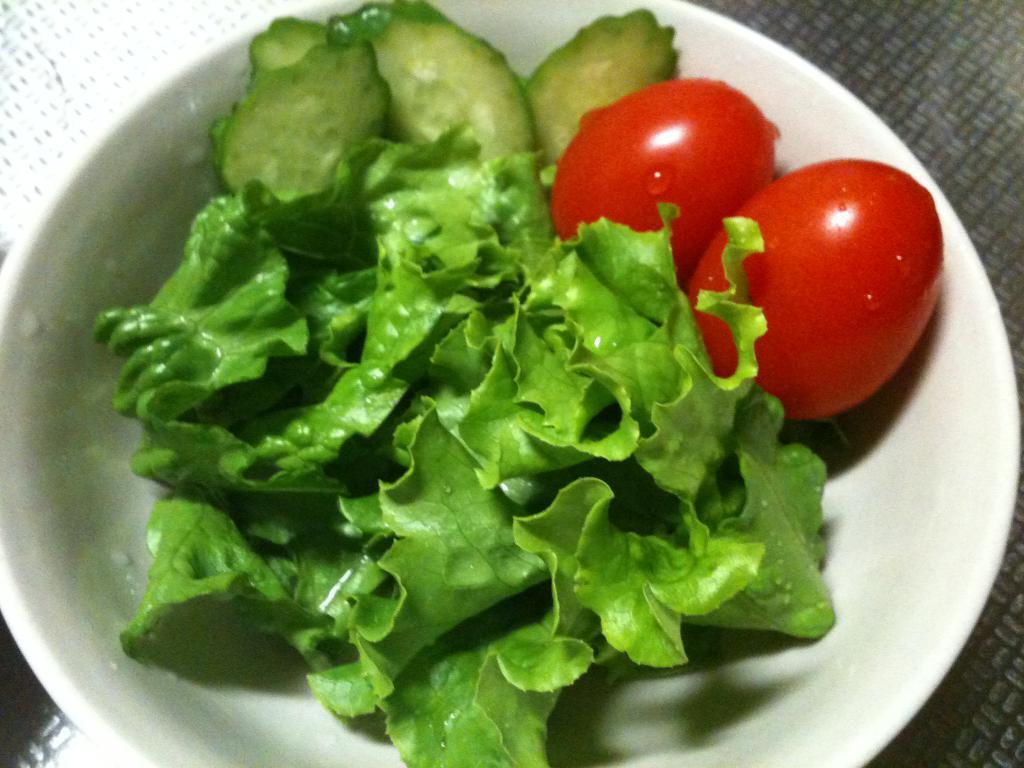Describe this image in one or two sentences. In the foreground of this image, there are leafy vegetables, few cut vegetables and two tomatoes in a bowl. On the right, there is a grey color object and on the left, there is a white color object. 